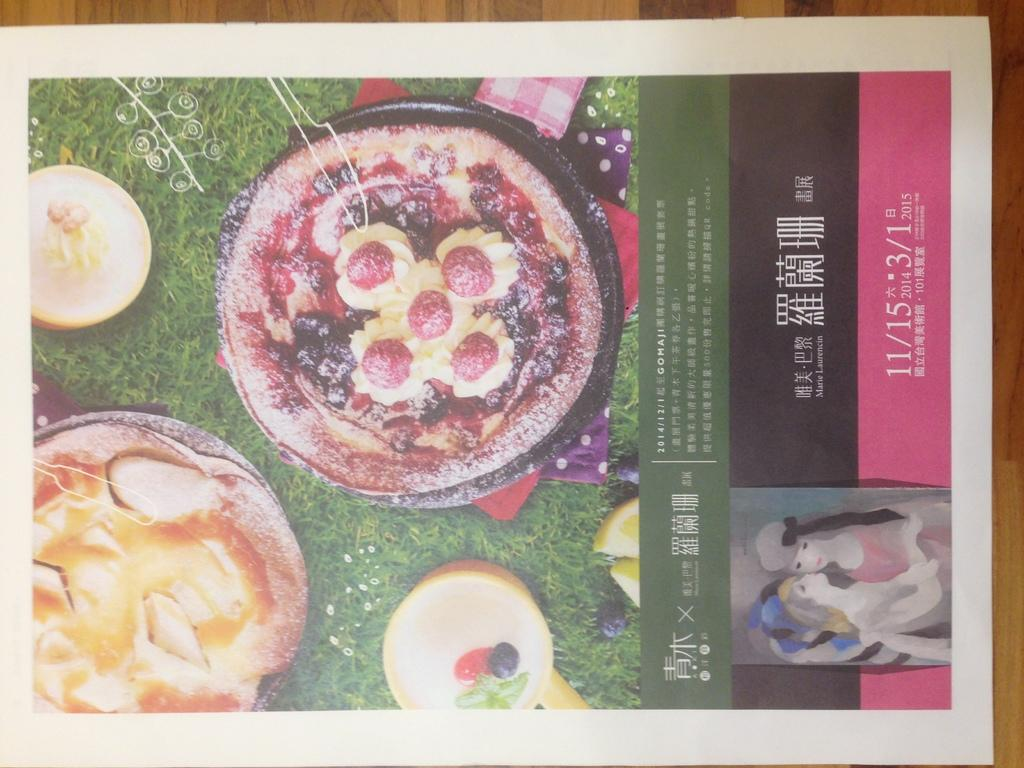<image>
Relay a brief, clear account of the picture shown. A poster for an event has the date of 11/15 at the bottom. 